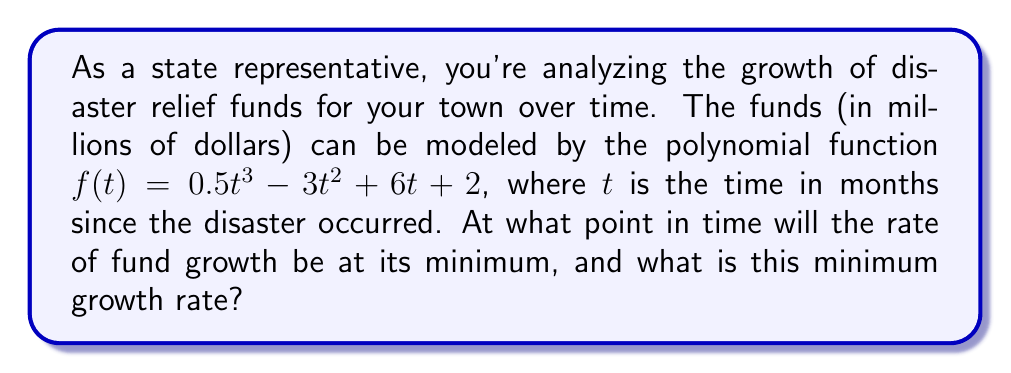What is the answer to this math problem? To solve this problem, we need to follow these steps:

1) The rate of growth is represented by the first derivative of the function. Let's find $f'(t)$:

   $f'(t) = 1.5t^2 - 6t + 6$

2) To find the minimum growth rate, we need to find where the second derivative equals zero. The second derivative is:

   $f''(t) = 3t - 6$

3) Set $f''(t) = 0$ and solve for $t$:

   $3t - 6 = 0$
   $3t = 6$
   $t = 2$

4) This critical point $t = 2$ represents the time when the growth rate is at its minimum.

5) To verify it's a minimum (not a maximum), we can check that $f'''(t) > 0$:

   $f'''(t) = 3$, which is indeed positive.

6) Now, let's calculate the minimum growth rate by plugging $t = 2$ into $f'(t)$:

   $f'(2) = 1.5(2)^2 - 6(2) + 6$
           $= 1.5(4) - 12 + 6$
           $= 6 - 12 + 6$
           $= 0$

Therefore, the minimum growth rate occurs 2 months after the disaster, and at this point, the growth rate is 0 million dollars per month.
Answer: The rate of fund growth will be at its minimum 2 months after the disaster, and the minimum growth rate is 0 million dollars per month. 